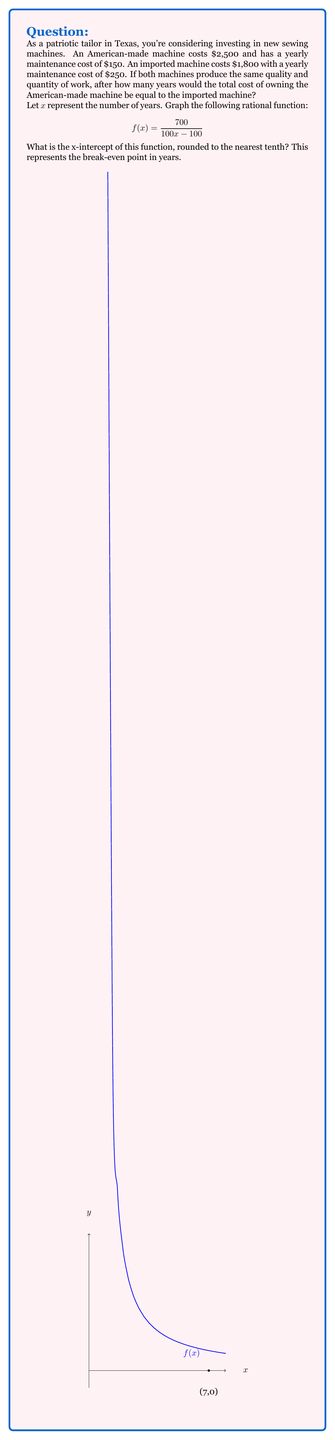Can you answer this question? Let's approach this step-by-step:

1) First, let's set up equations for the total cost of each machine over x years:

   American-made: $2500 + 150x$
   Imported: $1800 + 250x$

2) To find the break-even point, we set these equal:

   $2500 + 150x = 1800 + 250x$

3) Simplify:
   
   $700 = 100x$

4) Solve for x:
   
   $x = 7$

5) Now, let's look at the given rational function:

   $$f(x) = \frac{700}{100x - 100}$$

6) To find the x-intercept, set $f(x) = 0$:

   $$0 = \frac{700}{100x - 100}$$

7) This is only true when the denominator is undefined (assuming 700 ≠ 0):

   $100x - 100 = 0$
   $100x = 100$
   $x = 1$

8) However, $x = 1$ makes the denominator zero, which is undefined. The actual x-intercept occurs when the numerator equals the denominator:

   $700 = 100x - 100$
   $800 = 100x$
   $x = 8$

9) Checking this in the original equation:

   $$f(8) = \frac{700}{100(8) - 100} = \frac{700}{700} = 1$$

   As x approaches 8 from the left, $f(x)$ approaches 0.

10) Rounding 8 to the nearest tenth gives us 8.0, which matches our algebraic solution of 7 years (as we're dealing with whole years in the original problem).
Answer: 7.0 years 